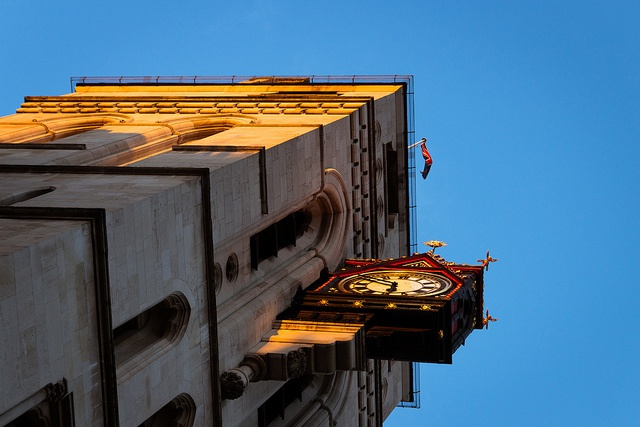Describe the objects in this image and their specific colors. I can see a clock in lightblue, black, maroon, brown, and khaki tones in this image. 